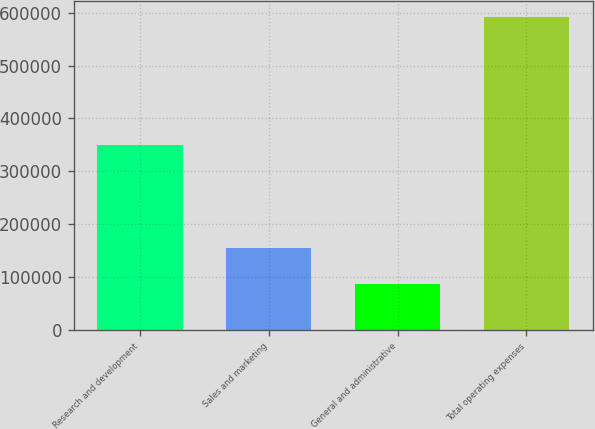<chart> <loc_0><loc_0><loc_500><loc_500><bar_chart><fcel>Research and development<fcel>Sales and marketing<fcel>General and administrative<fcel>Total operating expenses<nl><fcel>349594<fcel>155105<fcel>86798<fcel>591497<nl></chart> 